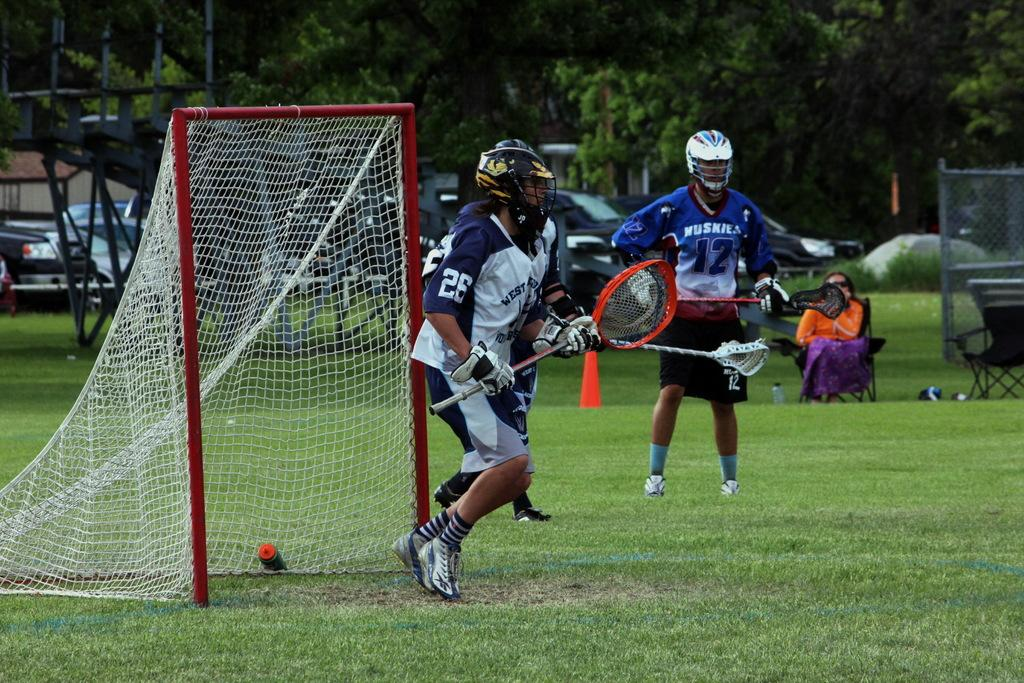Provide a one-sentence caption for the provided image. The Huskies were prepared to assist the goal but West was ready as well. 